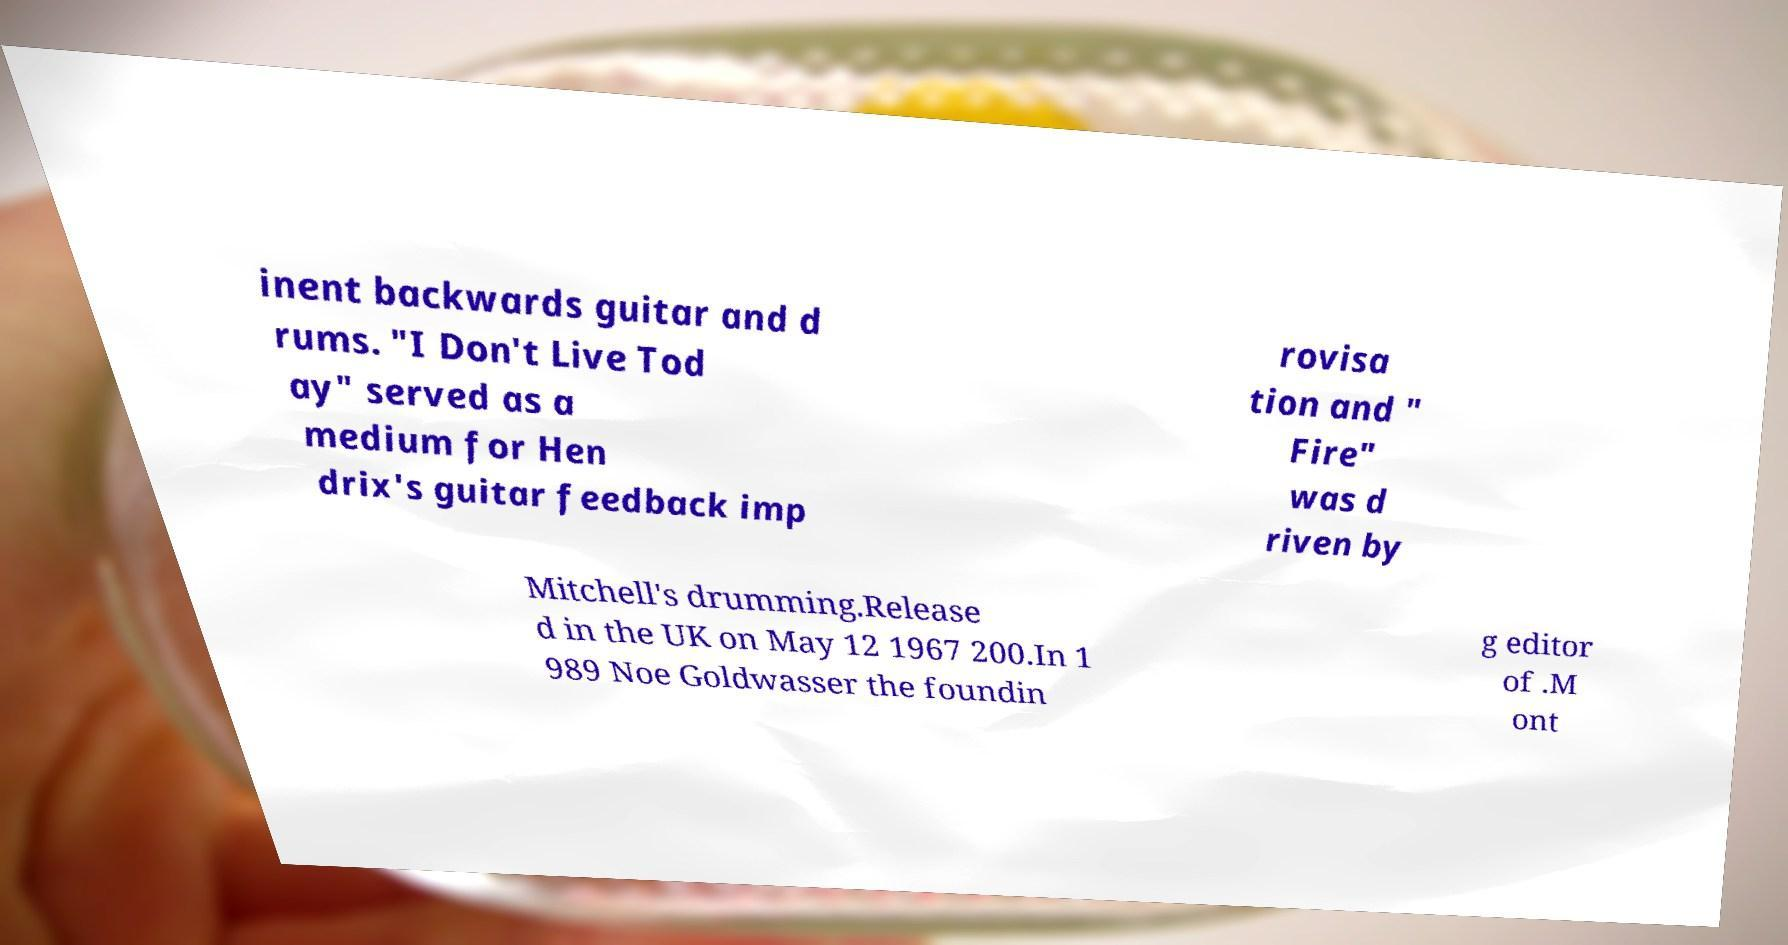I need the written content from this picture converted into text. Can you do that? inent backwards guitar and d rums. "I Don't Live Tod ay" served as a medium for Hen drix's guitar feedback imp rovisa tion and " Fire" was d riven by Mitchell's drumming.Release d in the UK on May 12 1967 200.In 1 989 Noe Goldwasser the foundin g editor of .M ont 